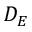<formula> <loc_0><loc_0><loc_500><loc_500>D _ { E }</formula> 